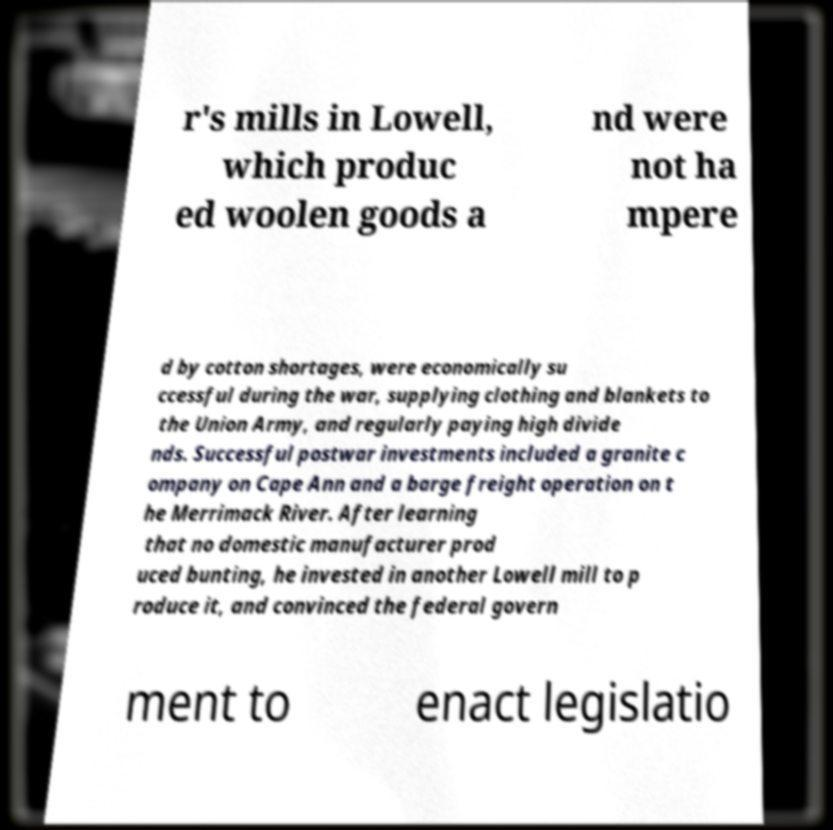I need the written content from this picture converted into text. Can you do that? r's mills in Lowell, which produc ed woolen goods a nd were not ha mpere d by cotton shortages, were economically su ccessful during the war, supplying clothing and blankets to the Union Army, and regularly paying high divide nds. Successful postwar investments included a granite c ompany on Cape Ann and a barge freight operation on t he Merrimack River. After learning that no domestic manufacturer prod uced bunting, he invested in another Lowell mill to p roduce it, and convinced the federal govern ment to enact legislatio 